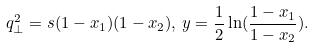<formula> <loc_0><loc_0><loc_500><loc_500>q _ { \perp } ^ { 2 } = s ( 1 - x _ { 1 } ) ( 1 - x _ { 2 } ) , \, y = \frac { 1 } { 2 } \ln ( \frac { 1 - x _ { 1 } } { 1 - x _ { 2 } } ) .</formula> 